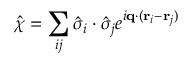<formula> <loc_0><loc_0><loc_500><loc_500>\hat { \chi } = \sum _ { i j } \hat { \sigma } _ { i } \cdot \hat { \sigma } _ { j } e ^ { i q \cdot ( r _ { i } - r _ { j } ) }</formula> 